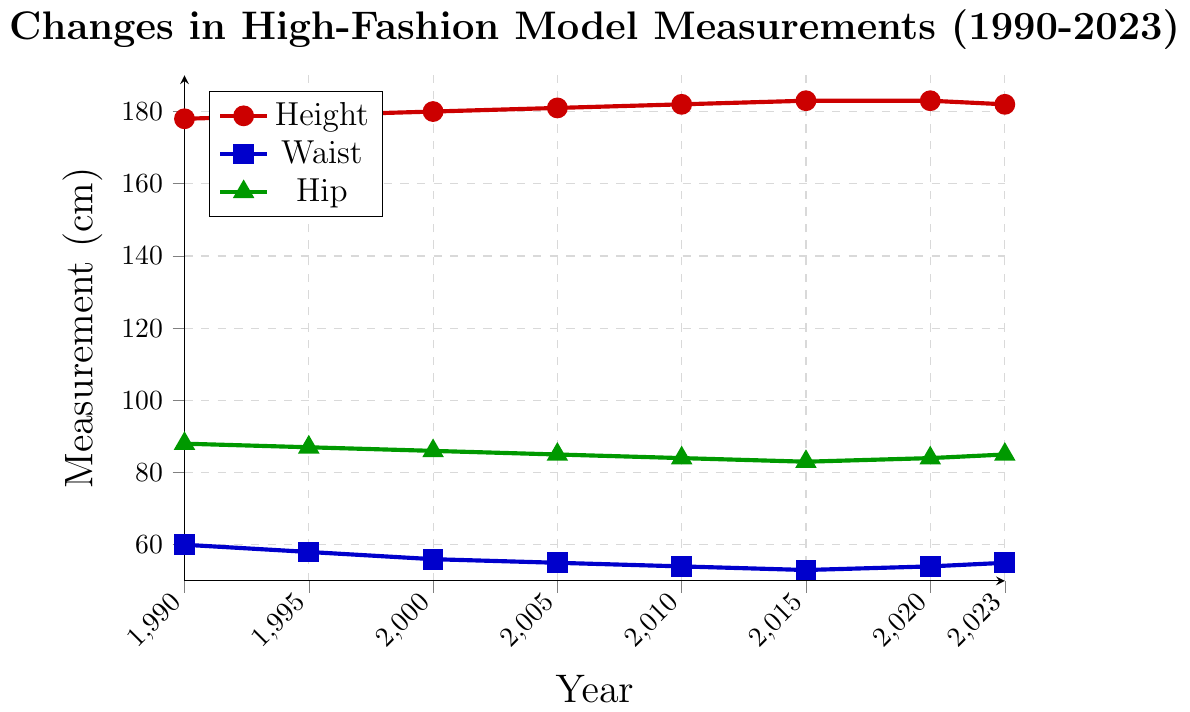what is the overall trend in preferred height for high-fashion models between 1990 and 2023? To identify the overall trend in the preferred height for high-fashion models between 1990 and 2023, we observe the height data from left (1990) to right (2023) on the plot. The height starts at 178 cm in 1990 and rises to 183 cm by 2015 before slightly dropping to 182 cm in 2023. Thus, the trend is generally upward with a slight decrease at the end.
Answer: Upward trend with a slight decrease at the end How did the waist measurement trend change from 1990 to 2023? From the plot, we observe the waist measurements decline from 60 cm in 1990 down to a minimum of 53 cm in 2015, then slightly rise back to 55 cm in 2023. This indicates a general downward trend with a slight increase at the end.
Answer: Downward trend with a slight increase at the end What year did the hip measurement reach its lowest value, and what was that value? By examining the plot for the hip measurement line (green), we see that the lowest value of 83 cm occurs in the year 2015.
Answer: 2015, 83 cm Between which years did the height of models increase the most? To determine the period of the greatest increase in height, we need to compare the differences between consecutive height values. The greatest increase is from 2010 (182 cm) to 2015 (183 cm), where the height increased by 1 cm.
Answer: 2010 to 2015 How does the waist measurement in 2000 compare to that in 2020? Look at the plot points for waist measurements in 2000 (56 cm) and in 2020 (54 cm). We see that the waist measurement in 2000 is 2 cm larger than in 2020.
Answer: 2000 waist is 2 cm larger than 2020 Calculate the average height of models in the given years. To find the average height, add all height values and divide by the number of years: (178+179+180+181+182+183+183+182) / 8 = 1448 / 8 = 181 cm.
Answer: 181 cm What is the difference in hip measurements between 1990 and 2015? The hip measurements are 88 cm in 1990 and 83 cm in 2015. Calculating the difference: 88 - 83 = 5 cm.
Answer: 5 cm Was there any year where both the waist and hip measurements increased compared to the previous year? Checking the plot, the waist and hip measurements both increase between 2015 (waist: 53 cm, hip: 83 cm) and 2020 (waist: 54 cm, hip: 84 cm).
Answer: Yes, in 2020 What is the percentage decrease in waist measurement from 1990 to 2015? Calculate the percentage decrease: ((60 - 53) / 60) * 100 = (7 / 60) * 100 ≈ 11.67%.
Answer: 11.67% 